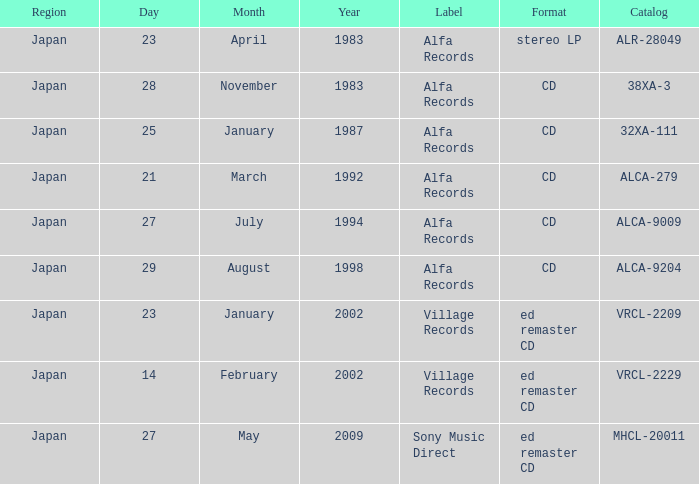Which label is dated February 14, 2002? Village Records. 